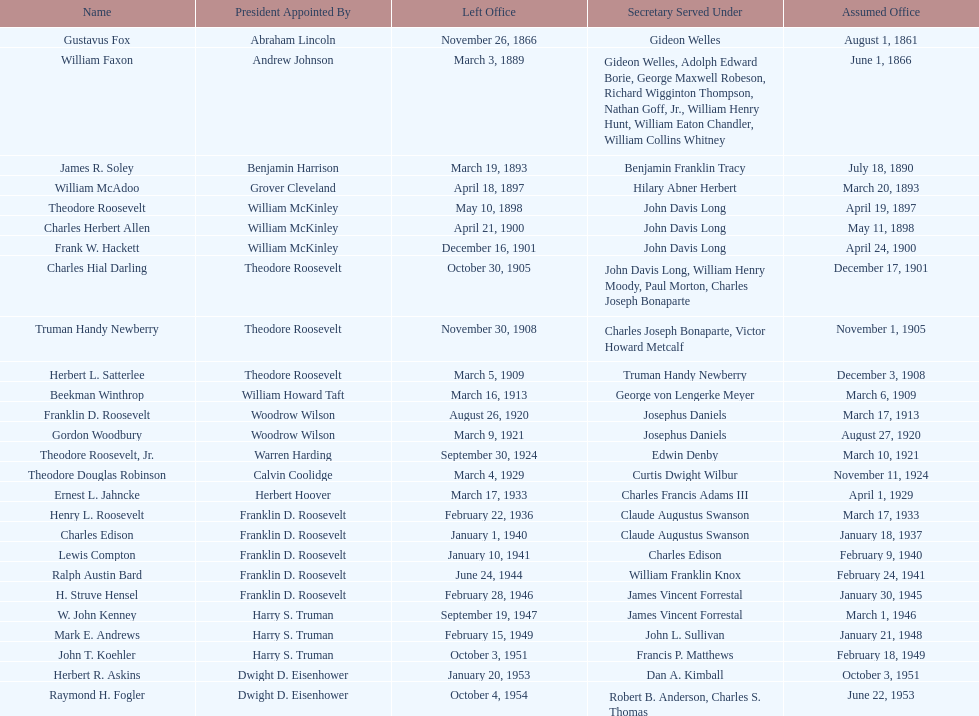Who was the first assistant secretary of the navy? Gustavus Fox. 